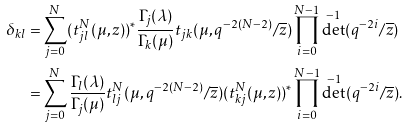<formula> <loc_0><loc_0><loc_500><loc_500>\delta _ { k l } = & \sum _ { j = 0 } ^ { N } ( t _ { j l } ^ { N } ( \mu , z ) ) ^ { * } \frac { \Gamma _ { j } ( \lambda ) } { \Gamma _ { k } ( \mu ) } t _ { j k } ( \mu , q ^ { - 2 ( N - 2 ) } / \overline { z } ) \prod _ { i = 0 } ^ { N - 1 } \det ^ { - 1 } ( q ^ { - 2 i } / \overline { z } ) \\ = & \sum _ { j = 0 } ^ { N } \frac { \Gamma _ { l } ( \lambda ) } { \Gamma _ { j } ( \mu ) } t ^ { N } _ { l j } ( \mu , q ^ { - 2 ( N - 2 ) } / \overline { z } ) ( t _ { k j } ^ { N } ( \mu , z ) ) ^ { * } \prod _ { i = 0 } ^ { N - 1 } \det ^ { - 1 } ( q ^ { - 2 i } / \overline { z } ) .</formula> 